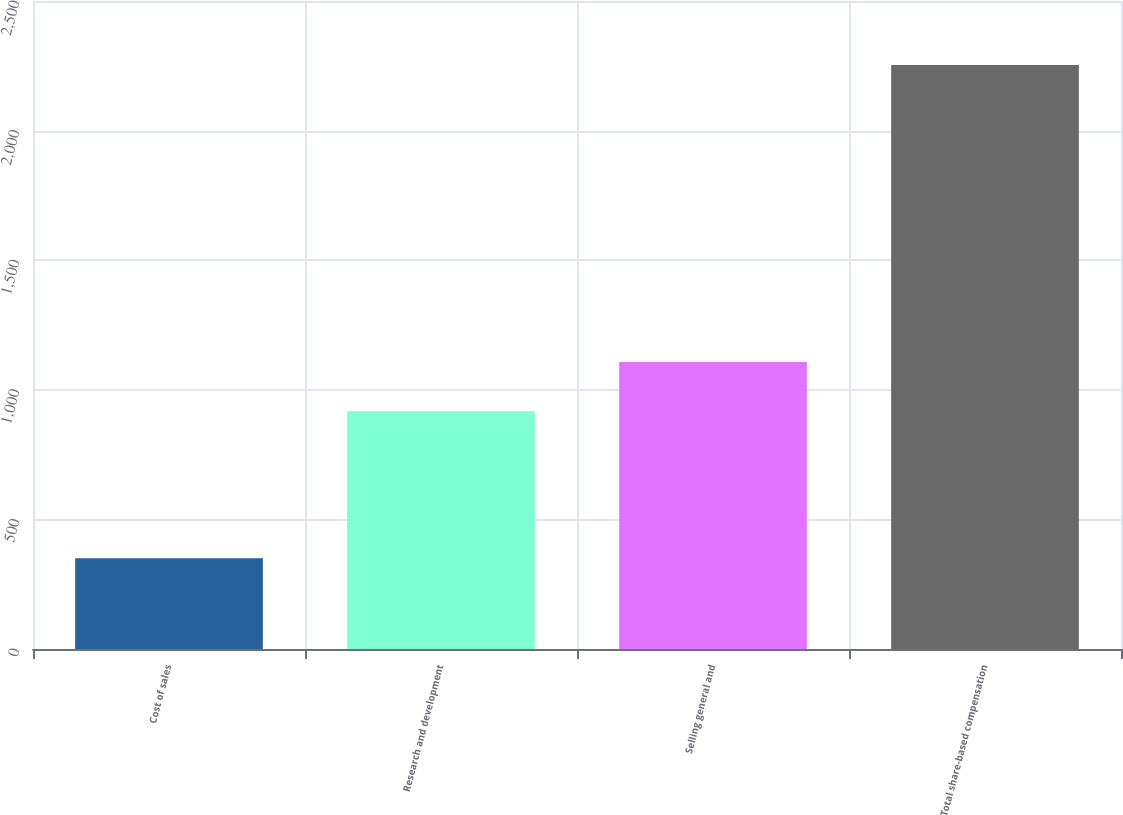<chart> <loc_0><loc_0><loc_500><loc_500><bar_chart><fcel>Cost of sales<fcel>Research and development<fcel>Selling general and<fcel>Total share-based compensation<nl><fcel>350<fcel>917<fcel>1107.3<fcel>2253<nl></chart> 